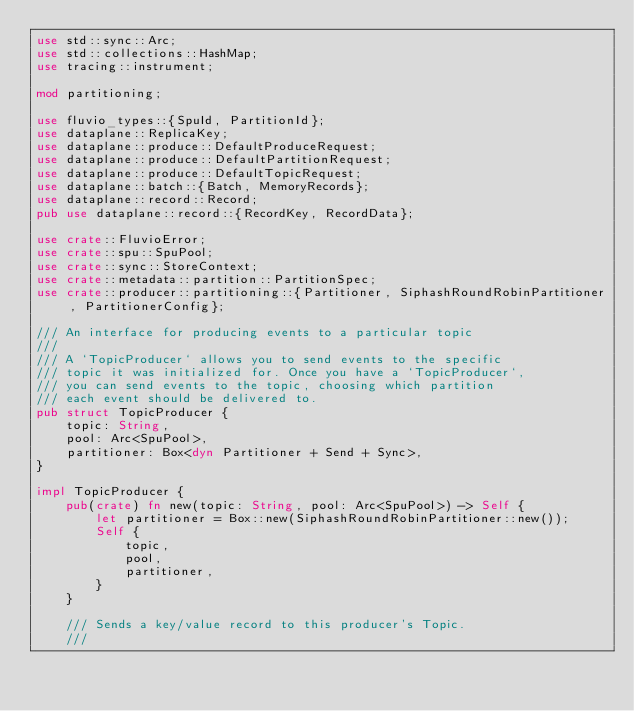Convert code to text. <code><loc_0><loc_0><loc_500><loc_500><_Rust_>use std::sync::Arc;
use std::collections::HashMap;
use tracing::instrument;

mod partitioning;

use fluvio_types::{SpuId, PartitionId};
use dataplane::ReplicaKey;
use dataplane::produce::DefaultProduceRequest;
use dataplane::produce::DefaultPartitionRequest;
use dataplane::produce::DefaultTopicRequest;
use dataplane::batch::{Batch, MemoryRecords};
use dataplane::record::Record;
pub use dataplane::record::{RecordKey, RecordData};

use crate::FluvioError;
use crate::spu::SpuPool;
use crate::sync::StoreContext;
use crate::metadata::partition::PartitionSpec;
use crate::producer::partitioning::{Partitioner, SiphashRoundRobinPartitioner, PartitionerConfig};

/// An interface for producing events to a particular topic
///
/// A `TopicProducer` allows you to send events to the specific
/// topic it was initialized for. Once you have a `TopicProducer`,
/// you can send events to the topic, choosing which partition
/// each event should be delivered to.
pub struct TopicProducer {
    topic: String,
    pool: Arc<SpuPool>,
    partitioner: Box<dyn Partitioner + Send + Sync>,
}

impl TopicProducer {
    pub(crate) fn new(topic: String, pool: Arc<SpuPool>) -> Self {
        let partitioner = Box::new(SiphashRoundRobinPartitioner::new());
        Self {
            topic,
            pool,
            partitioner,
        }
    }

    /// Sends a key/value record to this producer's Topic.
    ///</code> 